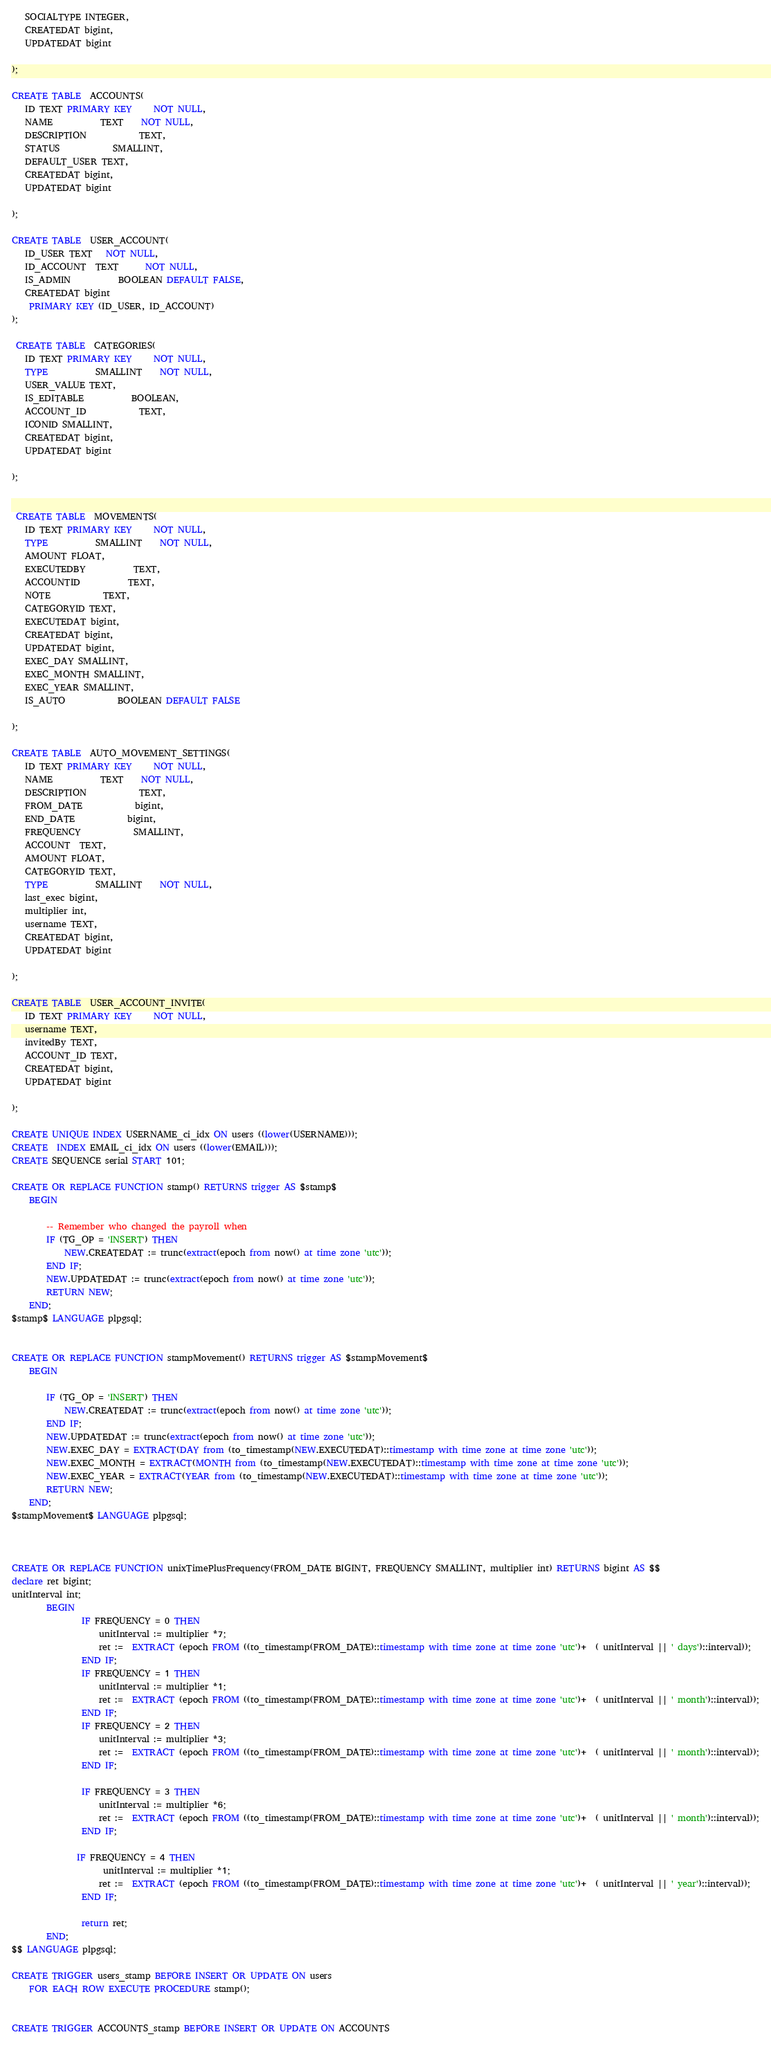Convert code to text. <code><loc_0><loc_0><loc_500><loc_500><_SQL_>   SOCIALTYPE INTEGER,
   CREATEDAT bigint,
   UPDATEDAT bigint

);

CREATE TABLE  ACCOUNTS(
   ID TEXT PRIMARY KEY     NOT NULL,
   NAME           TEXT    NOT NULL,
   DESCRIPTION            TEXT,
   STATUS            SMALLINT,
   DEFAULT_USER TEXT,
   CREATEDAT bigint,
   UPDATEDAT bigint

);

CREATE TABLE  USER_ACCOUNT(
   ID_USER TEXT   NOT NULL,
   ID_ACCOUNT  TEXT      NOT NULL,
   IS_ADMIN           BOOLEAN DEFAULT FALSE,
   CREATEDAT bigint
	PRIMARY KEY (ID_USER, ID_ACCOUNT)
);

 CREATE TABLE  CATEGORIES(
   ID TEXT PRIMARY KEY     NOT NULL,
   TYPE           SMALLINT    NOT NULL,
   USER_VALUE TEXT,
   IS_EDITABLE           BOOLEAN,
   ACCOUNT_ID            TEXT,
   ICONID SMALLINT,
   CREATEDAT bigint,
   UPDATEDAT bigint

);


 CREATE TABLE  MOVEMENTS(
   ID TEXT PRIMARY KEY     NOT NULL,
   TYPE           SMALLINT    NOT NULL,
   AMOUNT FLOAT,
   EXECUTEDBY           TEXT,
   ACCOUNTID           TEXT,
   NOTE            TEXT,
   CATEGORYID TEXT,
   EXECUTEDAT bigint,
   CREATEDAT bigint,
   UPDATEDAT bigint,
   EXEC_DAY SMALLINT,
   EXEC_MONTH SMALLINT,
   EXEC_YEAR SMALLINT,
   IS_AUTO            BOOLEAN DEFAULT FALSE

);

CREATE TABLE  AUTO_MOVEMENT_SETTINGS(
   ID TEXT PRIMARY KEY     NOT NULL,
   NAME           TEXT    NOT NULL,
   DESCRIPTION            TEXT,
   FROM_DATE            bigint,
   END_DATE            bigint,
   FREQUENCY            SMALLINT,
   ACCOUNT  TEXT,
   AMOUNT FLOAT,
   CATEGORYID TEXT,
   TYPE           SMALLINT    NOT NULL,
   last_exec bigint,
   multiplier int,
   username TEXT,
   CREATEDAT bigint,
   UPDATEDAT bigint

);

CREATE TABLE  USER_ACCOUNT_INVITE(
   ID TEXT PRIMARY KEY     NOT NULL,
   username TEXT,
   invitedBy TEXT,
   ACCOUNT_ID TEXT,
   CREATEDAT bigint,
   UPDATEDAT bigint

);

CREATE UNIQUE INDEX USERNAME_ci_idx ON users ((lower(USERNAME)));
CREATE  INDEX EMAIL_ci_idx ON users ((lower(EMAIL)));
CREATE SEQUENCE serial START 101;

CREATE OR REPLACE FUNCTION stamp() RETURNS trigger AS $stamp$
    BEGIN

        -- Remember who changed the payroll when
        IF (TG_OP = 'INSERT') THEN
        	NEW.CREATEDAT := trunc(extract(epoch from now() at time zone 'utc'));
        END IF;
        NEW.UPDATEDAT := trunc(extract(epoch from now() at time zone 'utc'));
        RETURN NEW;
    END;
$stamp$ LANGUAGE plpgsql;


CREATE OR REPLACE FUNCTION stampMovement() RETURNS trigger AS $stampMovement$
    BEGIN

        IF (TG_OP = 'INSERT') THEN
        	NEW.CREATEDAT := trunc(extract(epoch from now() at time zone 'utc'));
        END IF;
        NEW.UPDATEDAT := trunc(extract(epoch from now() at time zone 'utc'));
        NEW.EXEC_DAY = EXTRACT(DAY from (to_timestamp(NEW.EXECUTEDAT)::timestamp with time zone at time zone 'utc'));
        NEW.EXEC_MONTH = EXTRACT(MONTH from (to_timestamp(NEW.EXECUTEDAT)::timestamp with time zone at time zone 'utc'));
        NEW.EXEC_YEAR = EXTRACT(YEAR from (to_timestamp(NEW.EXECUTEDAT)::timestamp with time zone at time zone 'utc'));
        RETURN NEW;
    END;
$stampMovement$ LANGUAGE plpgsql;



CREATE OR REPLACE FUNCTION unixTimePlusFrequency(FROM_DATE BIGINT, FREQUENCY SMALLINT, multiplier int) RETURNS bigint AS $$
declare ret bigint;
unitInterval int;
        BEGIN
                IF FREQUENCY = 0 THEN
                	unitInterval := multiplier *7;
                	ret :=  EXTRACT (epoch FROM ((to_timestamp(FROM_DATE)::timestamp with time zone at time zone 'utc')+  ( unitInterval || ' days')::interval));
                END IF;
                IF FREQUENCY = 1 THEN
                	unitInterval := multiplier *1;
                	ret :=  EXTRACT (epoch FROM ((to_timestamp(FROM_DATE)::timestamp with time zone at time zone 'utc')+  ( unitInterval || ' month')::interval));
                END IF;
                IF FREQUENCY = 2 THEN
                 	unitInterval := multiplier *3;
                	ret :=  EXTRACT (epoch FROM ((to_timestamp(FROM_DATE)::timestamp with time zone at time zone 'utc')+  ( unitInterval || ' month')::interval));
                END IF;

                IF FREQUENCY = 3 THEN
                    unitInterval := multiplier *6;
                	ret :=  EXTRACT (epoch FROM ((to_timestamp(FROM_DATE)::timestamp with time zone at time zone 'utc')+  ( unitInterval || ' month')::interval));
                END IF;

               IF FREQUENCY = 4 THEN
                     unitInterval := multiplier *1;
                	ret :=  EXTRACT (epoch FROM ((to_timestamp(FROM_DATE)::timestamp with time zone at time zone 'utc')+  ( unitInterval || ' year')::interval));
                END IF;

                return ret;
        END;
$$ LANGUAGE plpgsql;

CREATE TRIGGER users_stamp BEFORE INSERT OR UPDATE ON users
    FOR EACH ROW EXECUTE PROCEDURE stamp();


CREATE TRIGGER ACCOUNTS_stamp BEFORE INSERT OR UPDATE ON ACCOUNTS</code> 